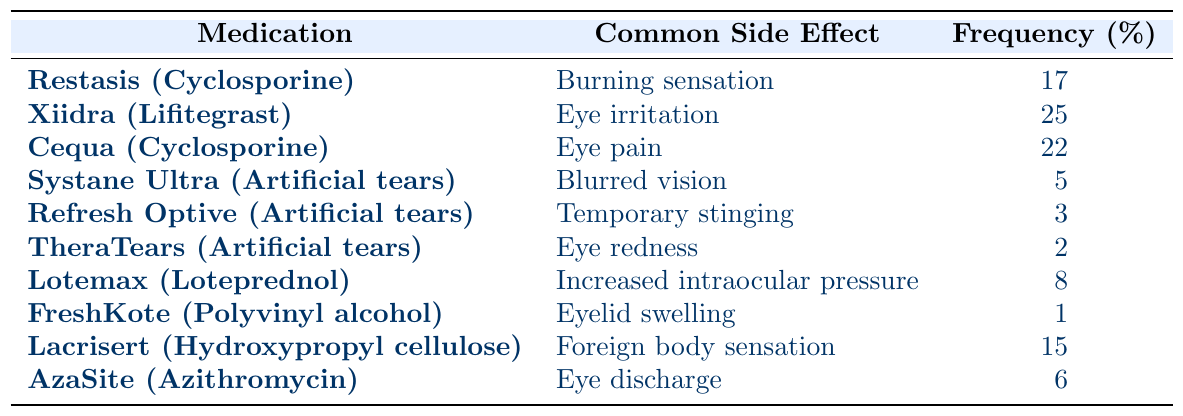What is the most common side effect among the listed medications? The table shows the frequency of common side effects for each medication. The side effect with the highest frequency percentage is "Eye irritation" related to Xiidra, which has a frequency of 25%.
Answer: 25% Which medication causes a burning sensation as a side effect? By looking at the table, "Restasis (Cyclosporine)" is the medication listed with "Burning sensation" as a common side effect.
Answer: Restasis (Cyclosporine) What is the combined frequency of side effects for artificial tear medications? The artificial tear medications listed are Systane Ultra, Refresh Optive, and TheraTears. Their frequencies are 5%, 3%, and 2% respectively. Summing these: 5 + 3 + 2 = 10%.
Answer: 10% Which side effect has the lowest reported frequency? In the table, "Eyelid swelling" associated with FreshKote has the lowest frequency of 1%, making it the least common side effect.
Answer: 1% Is the frequency of "Eye pain" higher than that of "Increased intraocular pressure"? "Eye pain" from Cequa has a frequency of 22%, while "Increased intraocular pressure" from Lotemax has 8%. Since 22% is greater than 8%, the statement is true.
Answer: Yes If we consider only the listed medications that contain cyclosporine, what is their average side effect frequency? The medications containing cyclosporine are Restasis (17%) and Cequa (22%). To find the average: (17 + 22) / 2 = 19.5%.
Answer: 19.5% Which medication has a side effect frequency below 5%? Reviewing the table, Refresh Optive (3%) and TheraTears (2%) both have side effect frequencies below 5%.
Answer: Refresh Optive and TheraTears What is the total frequency of side effects for medications with a known eye pain side effect? Cequa has "Eye pain" with 22%, and Lacrisert has "Foreign body sensation" reported at 15%. The total frequency is 22 + 15 = 37%.
Answer: 37% Which two medications have side effects related to discharge or sensation? The medications with related side effects are AzaSite (Eye discharge) and Lacrisert (Foreign body sensation).
Answer: AzaSite and Lacrisert Does any medication show a side effect related to temporary stinging? According to the table, Refresh Optive shows a side effect of "Temporary stinging" with a frequency of 3%.
Answer: Yes 